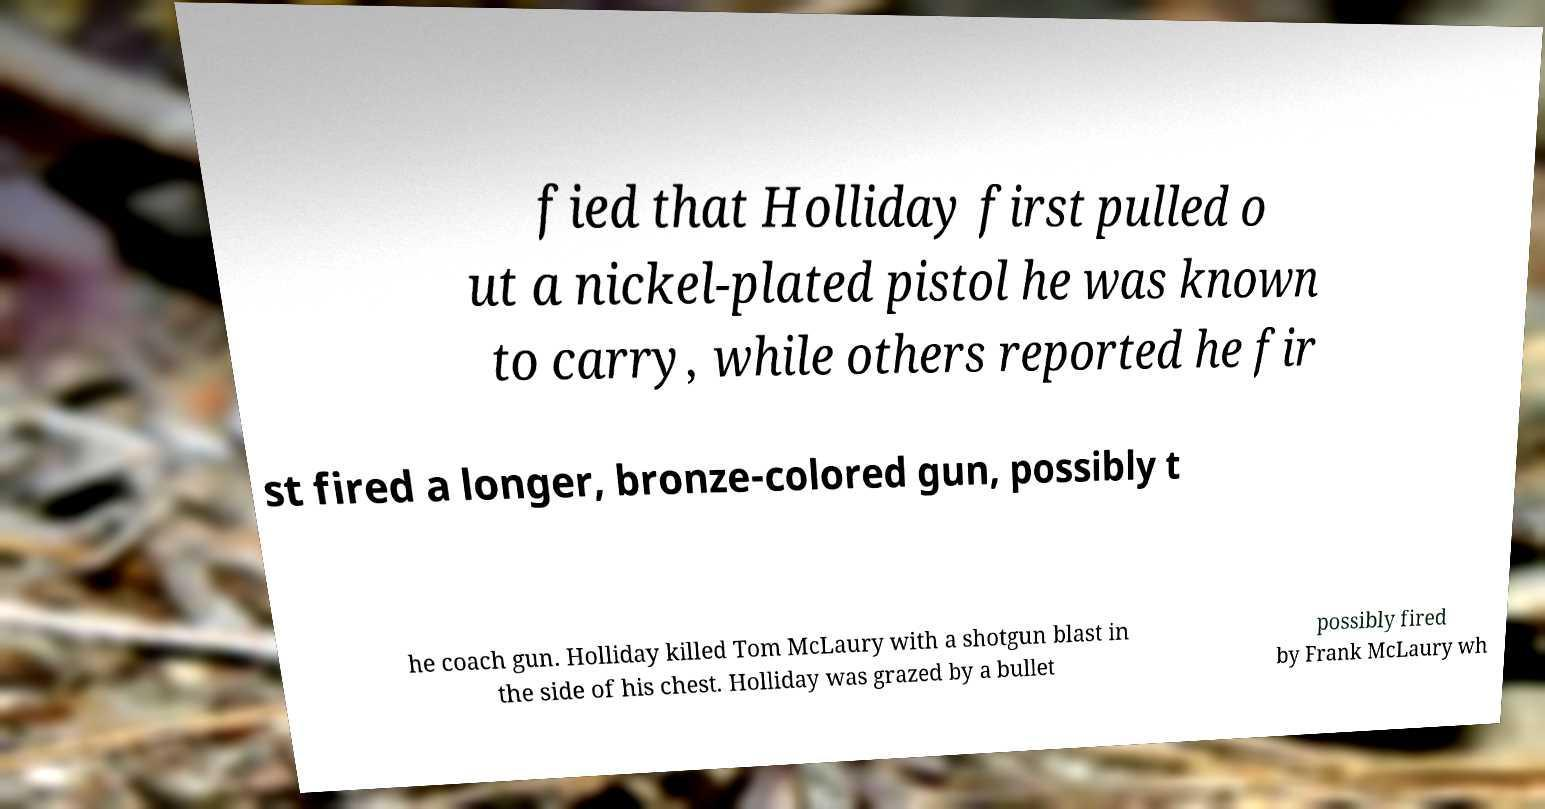I need the written content from this picture converted into text. Can you do that? fied that Holliday first pulled o ut a nickel-plated pistol he was known to carry, while others reported he fir st fired a longer, bronze-colored gun, possibly t he coach gun. Holliday killed Tom McLaury with a shotgun blast in the side of his chest. Holliday was grazed by a bullet possibly fired by Frank McLaury wh 